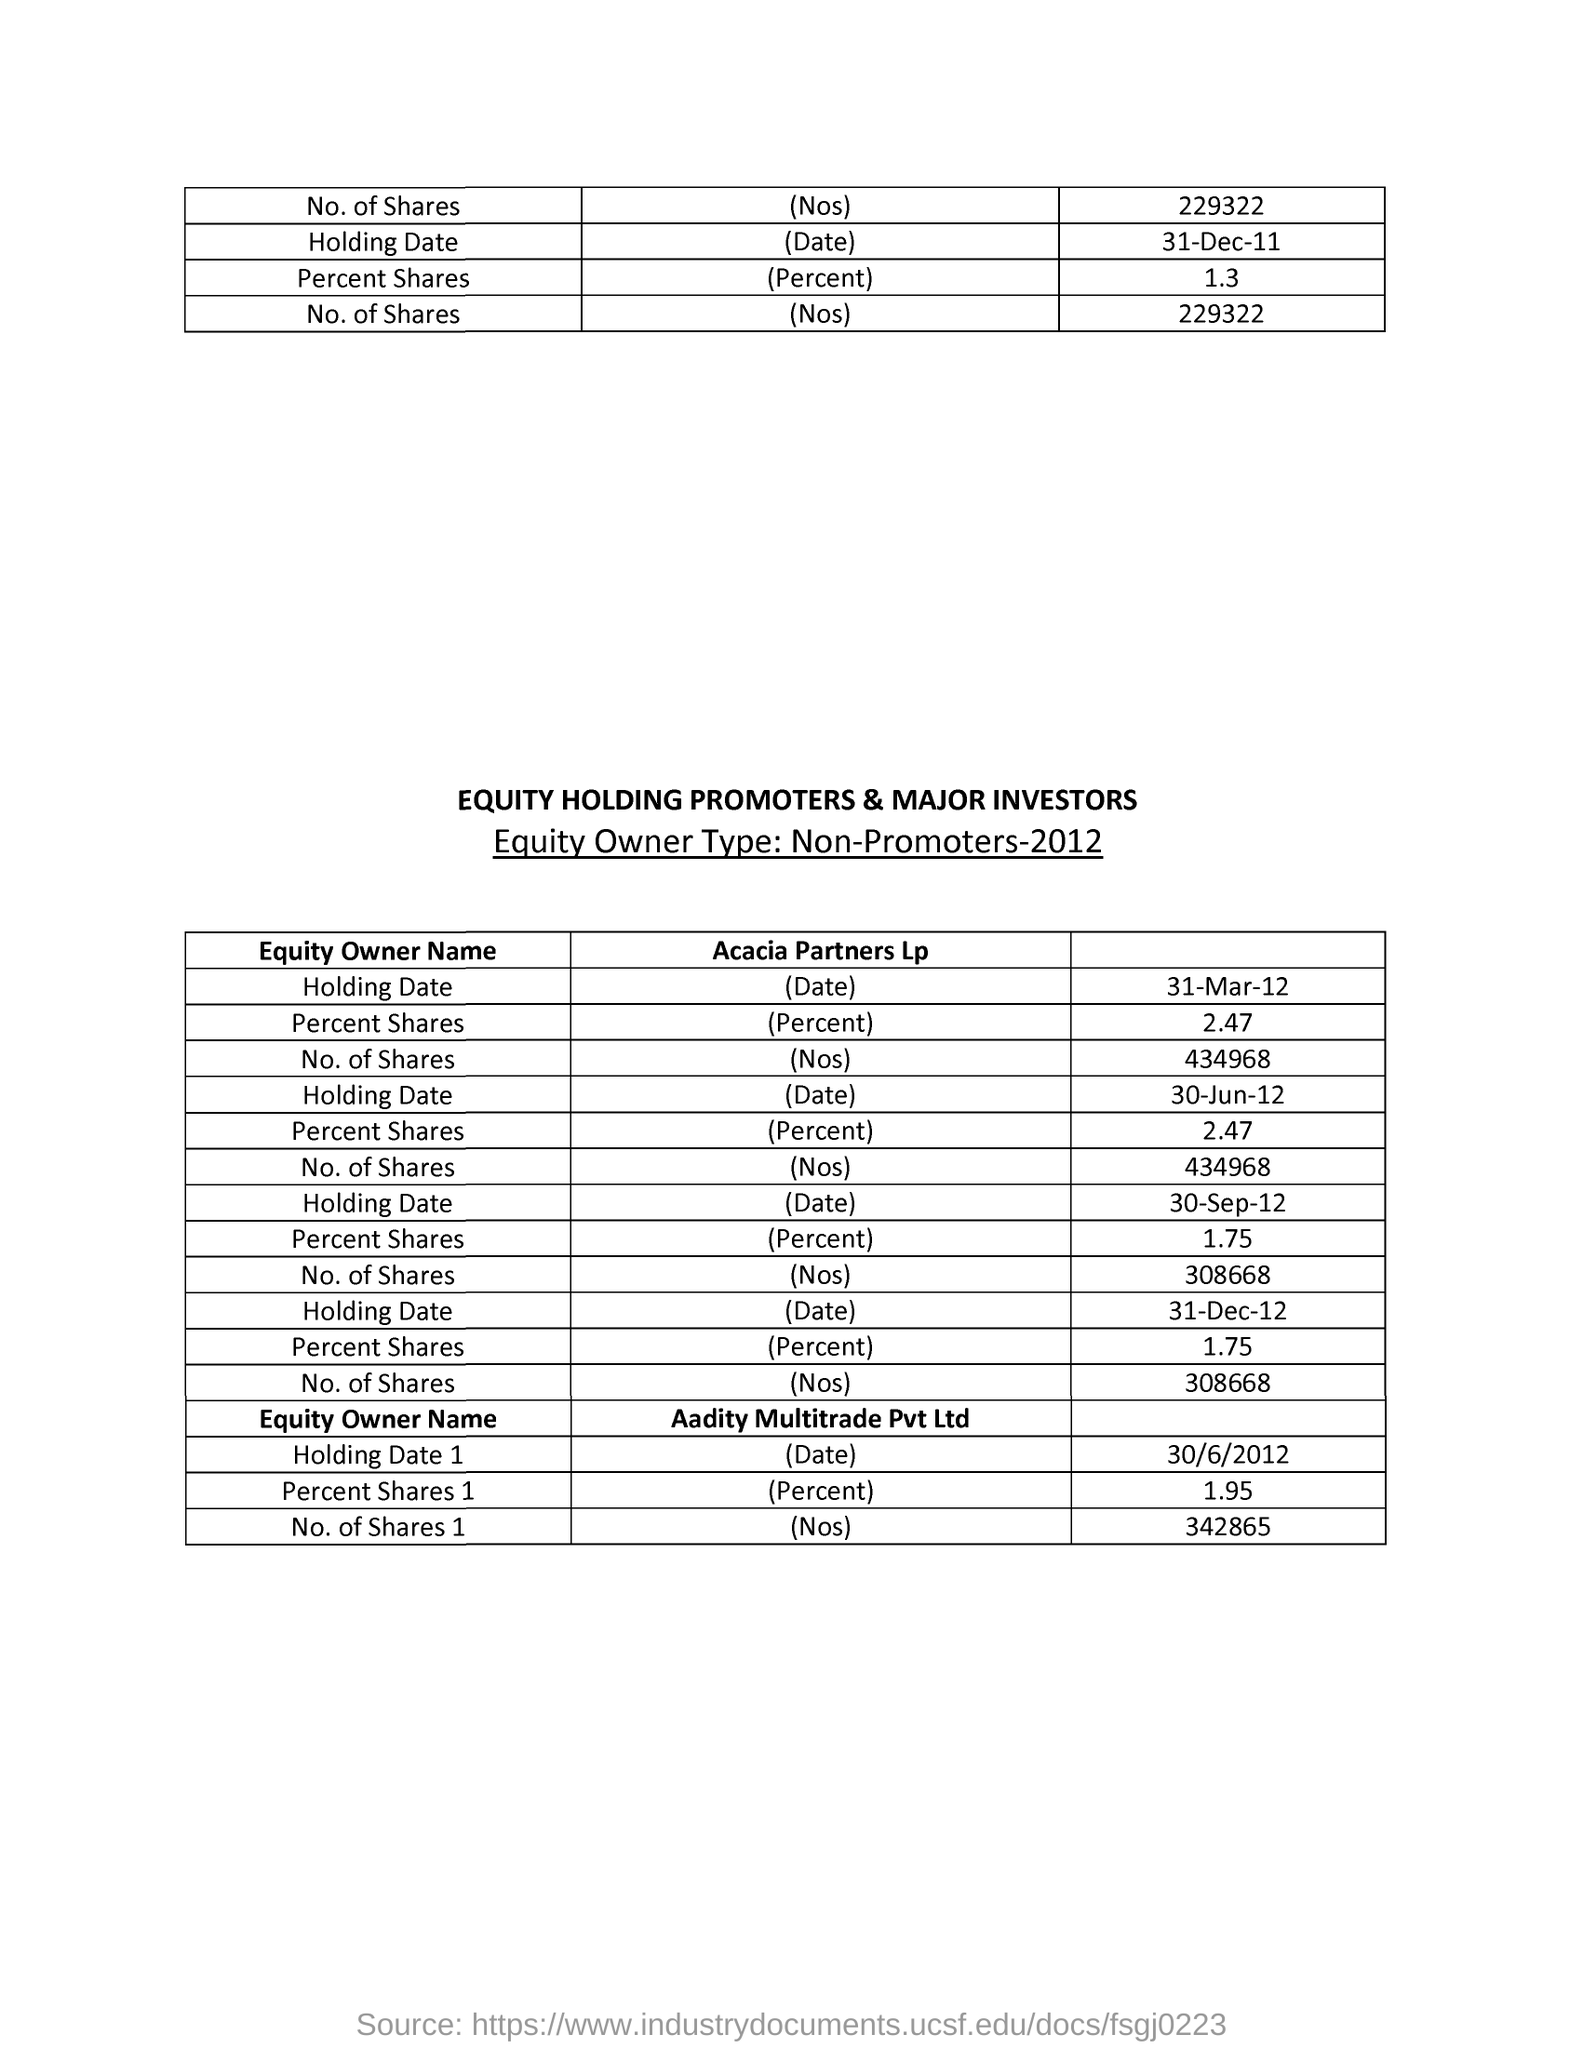What is the heading of the table given in capital letters?
Make the answer very short. EQUITY HOLDING PROMOTERS & MAJOR INVESTORS. What is the "Equity Owner Type:" mentioned?
Offer a terse response. Non-Promoters-2012. Details of "Equity Owner Type: Non-Promoters" of which year is given in the table?
Your answer should be very brief. 2012. What is the "Holding Date 1" mentioned in the table?
Offer a very short reply. 30/6/2012. What is the value of "Percent Shares1" mentioned in the table?
Provide a short and direct response. 1.95. What is the "No. of Shares 1" mentioned in the table?
Your answer should be compact. 342865. What is the heading of first column of second table?
Offer a terse response. Equity Owner Name. What is the "Holding Date" mentioned in the first table?
Your answer should be compact. 31-Dec-11. What is the value of "Percent Shares" given in the first table?
Make the answer very short. 1.3. 